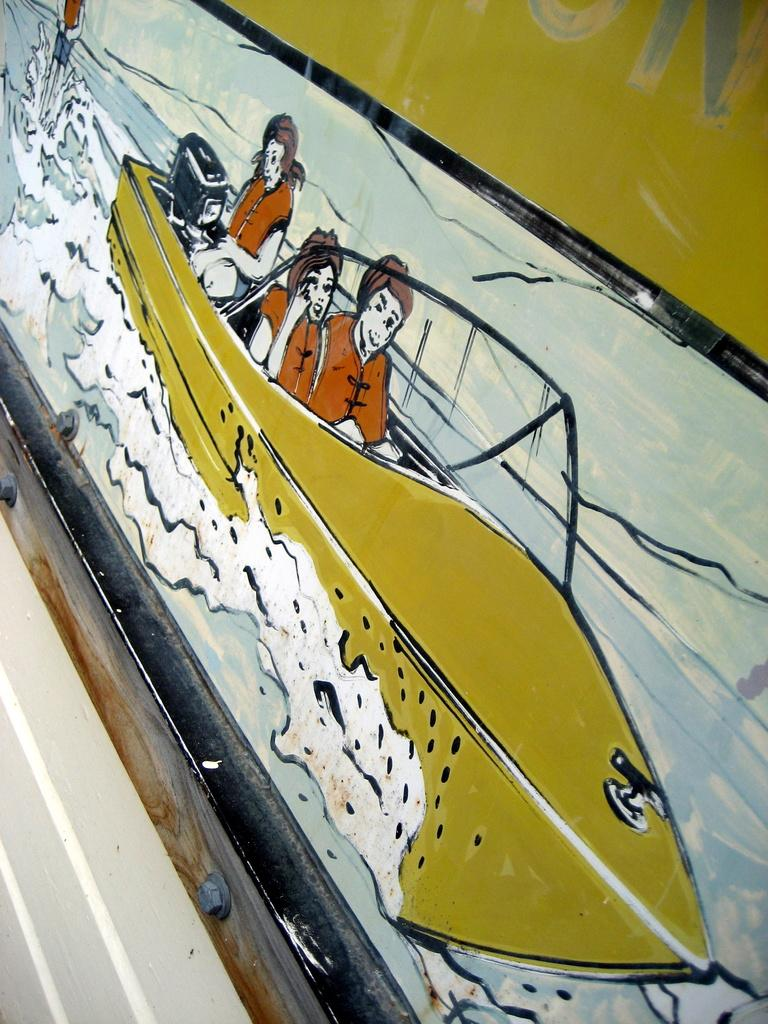What type of artwork is depicted in the image? The image is a painting. What is the main subject of the painting? There is there a boat in the painting. What is the setting of the painting? There is water in the painting. How many people are present in the painting? There are three persons in the painting. What type of society is depicted in the painting? The painting does not depict a society; it features a boat, water, and three persons. Can you see a zebra in the painting? No, there is no zebra present in the painting. 